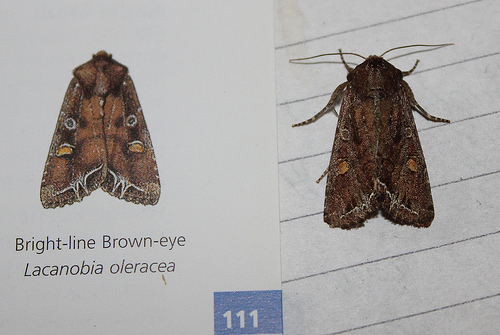<image>
Is the insect on the lined paper? Yes. Looking at the image, I can see the insect is positioned on top of the lined paper, with the lined paper providing support. 